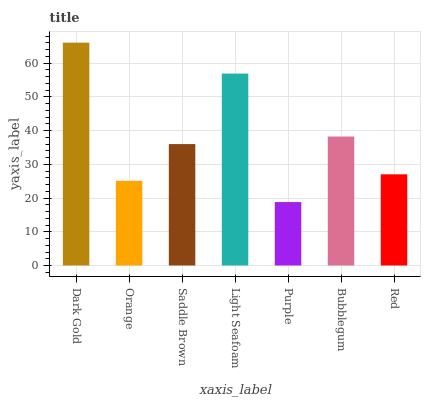Is Purple the minimum?
Answer yes or no. Yes. Is Dark Gold the maximum?
Answer yes or no. Yes. Is Orange the minimum?
Answer yes or no. No. Is Orange the maximum?
Answer yes or no. No. Is Dark Gold greater than Orange?
Answer yes or no. Yes. Is Orange less than Dark Gold?
Answer yes or no. Yes. Is Orange greater than Dark Gold?
Answer yes or no. No. Is Dark Gold less than Orange?
Answer yes or no. No. Is Saddle Brown the high median?
Answer yes or no. Yes. Is Saddle Brown the low median?
Answer yes or no. Yes. Is Dark Gold the high median?
Answer yes or no. No. Is Light Seafoam the low median?
Answer yes or no. No. 